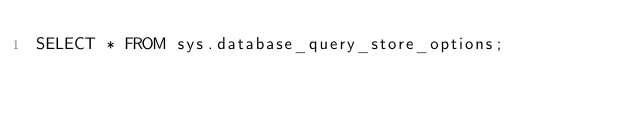Convert code to text. <code><loc_0><loc_0><loc_500><loc_500><_SQL_>SELECT * FROM sys.database_query_store_options;
</code> 